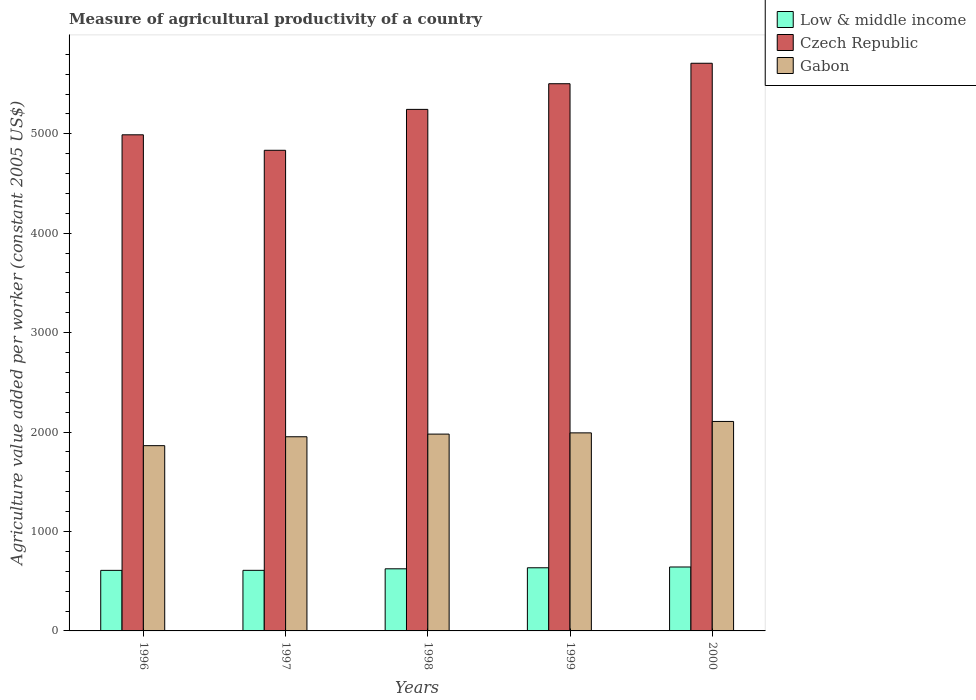How many different coloured bars are there?
Offer a terse response. 3. Are the number of bars on each tick of the X-axis equal?
Offer a terse response. Yes. How many bars are there on the 5th tick from the left?
Your response must be concise. 3. How many bars are there on the 5th tick from the right?
Provide a short and direct response. 3. What is the label of the 1st group of bars from the left?
Your response must be concise. 1996. What is the measure of agricultural productivity in Low & middle income in 1998?
Give a very brief answer. 624.77. Across all years, what is the maximum measure of agricultural productivity in Low & middle income?
Give a very brief answer. 643.04. Across all years, what is the minimum measure of agricultural productivity in Low & middle income?
Ensure brevity in your answer.  609. What is the total measure of agricultural productivity in Gabon in the graph?
Give a very brief answer. 9894.6. What is the difference between the measure of agricultural productivity in Czech Republic in 1998 and that in 1999?
Provide a short and direct response. -258.04. What is the difference between the measure of agricultural productivity in Gabon in 1999 and the measure of agricultural productivity in Low & middle income in 1996?
Provide a succinct answer. 1383. What is the average measure of agricultural productivity in Czech Republic per year?
Offer a very short reply. 5256.4. In the year 1998, what is the difference between the measure of agricultural productivity in Gabon and measure of agricultural productivity in Czech Republic?
Make the answer very short. -3265.87. What is the ratio of the measure of agricultural productivity in Low & middle income in 1996 to that in 2000?
Offer a terse response. 0.95. What is the difference between the highest and the second highest measure of agricultural productivity in Czech Republic?
Keep it short and to the point. 205.87. What is the difference between the highest and the lowest measure of agricultural productivity in Gabon?
Provide a succinct answer. 243.62. In how many years, is the measure of agricultural productivity in Czech Republic greater than the average measure of agricultural productivity in Czech Republic taken over all years?
Provide a short and direct response. 2. What does the 3rd bar from the left in 1997 represents?
Offer a terse response. Gabon. What does the 2nd bar from the right in 2000 represents?
Your answer should be very brief. Czech Republic. Are all the bars in the graph horizontal?
Offer a very short reply. No. Does the graph contain any zero values?
Offer a terse response. No. How are the legend labels stacked?
Offer a terse response. Vertical. What is the title of the graph?
Offer a terse response. Measure of agricultural productivity of a country. What is the label or title of the X-axis?
Your response must be concise. Years. What is the label or title of the Y-axis?
Make the answer very short. Agriculture value added per worker (constant 2005 US$). What is the Agriculture value added per worker (constant 2005 US$) of Low & middle income in 1996?
Keep it short and to the point. 609. What is the Agriculture value added per worker (constant 2005 US$) in Czech Republic in 1996?
Offer a very short reply. 4989.73. What is the Agriculture value added per worker (constant 2005 US$) of Gabon in 1996?
Offer a terse response. 1863.27. What is the Agriculture value added per worker (constant 2005 US$) in Low & middle income in 1997?
Your answer should be very brief. 609.28. What is the Agriculture value added per worker (constant 2005 US$) in Czech Republic in 1997?
Your answer should be very brief. 4833.99. What is the Agriculture value added per worker (constant 2005 US$) in Gabon in 1997?
Your answer should be compact. 1952.85. What is the Agriculture value added per worker (constant 2005 US$) in Low & middle income in 1998?
Provide a short and direct response. 624.77. What is the Agriculture value added per worker (constant 2005 US$) of Czech Republic in 1998?
Provide a short and direct response. 5245.45. What is the Agriculture value added per worker (constant 2005 US$) of Gabon in 1998?
Offer a terse response. 1979.57. What is the Agriculture value added per worker (constant 2005 US$) in Low & middle income in 1999?
Give a very brief answer. 635.15. What is the Agriculture value added per worker (constant 2005 US$) in Czech Republic in 1999?
Ensure brevity in your answer.  5503.49. What is the Agriculture value added per worker (constant 2005 US$) in Gabon in 1999?
Offer a terse response. 1992. What is the Agriculture value added per worker (constant 2005 US$) in Low & middle income in 2000?
Provide a succinct answer. 643.04. What is the Agriculture value added per worker (constant 2005 US$) of Czech Republic in 2000?
Offer a terse response. 5709.36. What is the Agriculture value added per worker (constant 2005 US$) of Gabon in 2000?
Provide a short and direct response. 2106.9. Across all years, what is the maximum Agriculture value added per worker (constant 2005 US$) in Low & middle income?
Give a very brief answer. 643.04. Across all years, what is the maximum Agriculture value added per worker (constant 2005 US$) of Czech Republic?
Keep it short and to the point. 5709.36. Across all years, what is the maximum Agriculture value added per worker (constant 2005 US$) of Gabon?
Provide a succinct answer. 2106.9. Across all years, what is the minimum Agriculture value added per worker (constant 2005 US$) of Low & middle income?
Your answer should be very brief. 609. Across all years, what is the minimum Agriculture value added per worker (constant 2005 US$) in Czech Republic?
Offer a terse response. 4833.99. Across all years, what is the minimum Agriculture value added per worker (constant 2005 US$) of Gabon?
Ensure brevity in your answer.  1863.27. What is the total Agriculture value added per worker (constant 2005 US$) of Low & middle income in the graph?
Keep it short and to the point. 3121.24. What is the total Agriculture value added per worker (constant 2005 US$) of Czech Republic in the graph?
Offer a terse response. 2.63e+04. What is the total Agriculture value added per worker (constant 2005 US$) in Gabon in the graph?
Offer a very short reply. 9894.6. What is the difference between the Agriculture value added per worker (constant 2005 US$) of Low & middle income in 1996 and that in 1997?
Provide a short and direct response. -0.28. What is the difference between the Agriculture value added per worker (constant 2005 US$) in Czech Republic in 1996 and that in 1997?
Provide a succinct answer. 155.74. What is the difference between the Agriculture value added per worker (constant 2005 US$) in Gabon in 1996 and that in 1997?
Ensure brevity in your answer.  -89.58. What is the difference between the Agriculture value added per worker (constant 2005 US$) in Low & middle income in 1996 and that in 1998?
Your answer should be compact. -15.77. What is the difference between the Agriculture value added per worker (constant 2005 US$) in Czech Republic in 1996 and that in 1998?
Your answer should be very brief. -255.72. What is the difference between the Agriculture value added per worker (constant 2005 US$) in Gabon in 1996 and that in 1998?
Give a very brief answer. -116.3. What is the difference between the Agriculture value added per worker (constant 2005 US$) of Low & middle income in 1996 and that in 1999?
Give a very brief answer. -26.15. What is the difference between the Agriculture value added per worker (constant 2005 US$) of Czech Republic in 1996 and that in 1999?
Your response must be concise. -513.76. What is the difference between the Agriculture value added per worker (constant 2005 US$) of Gabon in 1996 and that in 1999?
Your answer should be very brief. -128.73. What is the difference between the Agriculture value added per worker (constant 2005 US$) of Low & middle income in 1996 and that in 2000?
Provide a succinct answer. -34.04. What is the difference between the Agriculture value added per worker (constant 2005 US$) of Czech Republic in 1996 and that in 2000?
Provide a succinct answer. -719.63. What is the difference between the Agriculture value added per worker (constant 2005 US$) in Gabon in 1996 and that in 2000?
Ensure brevity in your answer.  -243.62. What is the difference between the Agriculture value added per worker (constant 2005 US$) in Low & middle income in 1997 and that in 1998?
Ensure brevity in your answer.  -15.5. What is the difference between the Agriculture value added per worker (constant 2005 US$) of Czech Republic in 1997 and that in 1998?
Make the answer very short. -411.46. What is the difference between the Agriculture value added per worker (constant 2005 US$) in Gabon in 1997 and that in 1998?
Keep it short and to the point. -26.72. What is the difference between the Agriculture value added per worker (constant 2005 US$) of Low & middle income in 1997 and that in 1999?
Your answer should be very brief. -25.87. What is the difference between the Agriculture value added per worker (constant 2005 US$) in Czech Republic in 1997 and that in 1999?
Offer a very short reply. -669.5. What is the difference between the Agriculture value added per worker (constant 2005 US$) of Gabon in 1997 and that in 1999?
Provide a succinct answer. -39.15. What is the difference between the Agriculture value added per worker (constant 2005 US$) of Low & middle income in 1997 and that in 2000?
Make the answer very short. -33.76. What is the difference between the Agriculture value added per worker (constant 2005 US$) of Czech Republic in 1997 and that in 2000?
Your response must be concise. -875.37. What is the difference between the Agriculture value added per worker (constant 2005 US$) in Gabon in 1997 and that in 2000?
Offer a terse response. -154.04. What is the difference between the Agriculture value added per worker (constant 2005 US$) of Low & middle income in 1998 and that in 1999?
Give a very brief answer. -10.38. What is the difference between the Agriculture value added per worker (constant 2005 US$) in Czech Republic in 1998 and that in 1999?
Keep it short and to the point. -258.04. What is the difference between the Agriculture value added per worker (constant 2005 US$) of Gabon in 1998 and that in 1999?
Give a very brief answer. -12.43. What is the difference between the Agriculture value added per worker (constant 2005 US$) in Low & middle income in 1998 and that in 2000?
Keep it short and to the point. -18.26. What is the difference between the Agriculture value added per worker (constant 2005 US$) in Czech Republic in 1998 and that in 2000?
Ensure brevity in your answer.  -463.91. What is the difference between the Agriculture value added per worker (constant 2005 US$) in Gabon in 1998 and that in 2000?
Make the answer very short. -127.32. What is the difference between the Agriculture value added per worker (constant 2005 US$) of Low & middle income in 1999 and that in 2000?
Provide a succinct answer. -7.89. What is the difference between the Agriculture value added per worker (constant 2005 US$) in Czech Republic in 1999 and that in 2000?
Offer a terse response. -205.87. What is the difference between the Agriculture value added per worker (constant 2005 US$) of Gabon in 1999 and that in 2000?
Your answer should be very brief. -114.89. What is the difference between the Agriculture value added per worker (constant 2005 US$) in Low & middle income in 1996 and the Agriculture value added per worker (constant 2005 US$) in Czech Republic in 1997?
Offer a terse response. -4224.99. What is the difference between the Agriculture value added per worker (constant 2005 US$) of Low & middle income in 1996 and the Agriculture value added per worker (constant 2005 US$) of Gabon in 1997?
Provide a succinct answer. -1343.85. What is the difference between the Agriculture value added per worker (constant 2005 US$) in Czech Republic in 1996 and the Agriculture value added per worker (constant 2005 US$) in Gabon in 1997?
Give a very brief answer. 3036.88. What is the difference between the Agriculture value added per worker (constant 2005 US$) in Low & middle income in 1996 and the Agriculture value added per worker (constant 2005 US$) in Czech Republic in 1998?
Keep it short and to the point. -4636.45. What is the difference between the Agriculture value added per worker (constant 2005 US$) in Low & middle income in 1996 and the Agriculture value added per worker (constant 2005 US$) in Gabon in 1998?
Give a very brief answer. -1370.57. What is the difference between the Agriculture value added per worker (constant 2005 US$) of Czech Republic in 1996 and the Agriculture value added per worker (constant 2005 US$) of Gabon in 1998?
Make the answer very short. 3010.16. What is the difference between the Agriculture value added per worker (constant 2005 US$) in Low & middle income in 1996 and the Agriculture value added per worker (constant 2005 US$) in Czech Republic in 1999?
Your response must be concise. -4894.49. What is the difference between the Agriculture value added per worker (constant 2005 US$) of Low & middle income in 1996 and the Agriculture value added per worker (constant 2005 US$) of Gabon in 1999?
Provide a succinct answer. -1383. What is the difference between the Agriculture value added per worker (constant 2005 US$) in Czech Republic in 1996 and the Agriculture value added per worker (constant 2005 US$) in Gabon in 1999?
Make the answer very short. 2997.73. What is the difference between the Agriculture value added per worker (constant 2005 US$) of Low & middle income in 1996 and the Agriculture value added per worker (constant 2005 US$) of Czech Republic in 2000?
Your answer should be very brief. -5100.36. What is the difference between the Agriculture value added per worker (constant 2005 US$) in Low & middle income in 1996 and the Agriculture value added per worker (constant 2005 US$) in Gabon in 2000?
Your answer should be very brief. -1497.9. What is the difference between the Agriculture value added per worker (constant 2005 US$) in Czech Republic in 1996 and the Agriculture value added per worker (constant 2005 US$) in Gabon in 2000?
Offer a terse response. 2882.83. What is the difference between the Agriculture value added per worker (constant 2005 US$) in Low & middle income in 1997 and the Agriculture value added per worker (constant 2005 US$) in Czech Republic in 1998?
Your response must be concise. -4636.17. What is the difference between the Agriculture value added per worker (constant 2005 US$) of Low & middle income in 1997 and the Agriculture value added per worker (constant 2005 US$) of Gabon in 1998?
Offer a very short reply. -1370.3. What is the difference between the Agriculture value added per worker (constant 2005 US$) of Czech Republic in 1997 and the Agriculture value added per worker (constant 2005 US$) of Gabon in 1998?
Give a very brief answer. 2854.42. What is the difference between the Agriculture value added per worker (constant 2005 US$) of Low & middle income in 1997 and the Agriculture value added per worker (constant 2005 US$) of Czech Republic in 1999?
Provide a short and direct response. -4894.21. What is the difference between the Agriculture value added per worker (constant 2005 US$) of Low & middle income in 1997 and the Agriculture value added per worker (constant 2005 US$) of Gabon in 1999?
Offer a very short reply. -1382.72. What is the difference between the Agriculture value added per worker (constant 2005 US$) of Czech Republic in 1997 and the Agriculture value added per worker (constant 2005 US$) of Gabon in 1999?
Keep it short and to the point. 2841.99. What is the difference between the Agriculture value added per worker (constant 2005 US$) of Low & middle income in 1997 and the Agriculture value added per worker (constant 2005 US$) of Czech Republic in 2000?
Give a very brief answer. -5100.08. What is the difference between the Agriculture value added per worker (constant 2005 US$) in Low & middle income in 1997 and the Agriculture value added per worker (constant 2005 US$) in Gabon in 2000?
Give a very brief answer. -1497.62. What is the difference between the Agriculture value added per worker (constant 2005 US$) in Czech Republic in 1997 and the Agriculture value added per worker (constant 2005 US$) in Gabon in 2000?
Your response must be concise. 2727.09. What is the difference between the Agriculture value added per worker (constant 2005 US$) in Low & middle income in 1998 and the Agriculture value added per worker (constant 2005 US$) in Czech Republic in 1999?
Provide a succinct answer. -4878.71. What is the difference between the Agriculture value added per worker (constant 2005 US$) of Low & middle income in 1998 and the Agriculture value added per worker (constant 2005 US$) of Gabon in 1999?
Make the answer very short. -1367.23. What is the difference between the Agriculture value added per worker (constant 2005 US$) of Czech Republic in 1998 and the Agriculture value added per worker (constant 2005 US$) of Gabon in 1999?
Ensure brevity in your answer.  3253.45. What is the difference between the Agriculture value added per worker (constant 2005 US$) of Low & middle income in 1998 and the Agriculture value added per worker (constant 2005 US$) of Czech Republic in 2000?
Your response must be concise. -5084.59. What is the difference between the Agriculture value added per worker (constant 2005 US$) of Low & middle income in 1998 and the Agriculture value added per worker (constant 2005 US$) of Gabon in 2000?
Ensure brevity in your answer.  -1482.12. What is the difference between the Agriculture value added per worker (constant 2005 US$) in Czech Republic in 1998 and the Agriculture value added per worker (constant 2005 US$) in Gabon in 2000?
Offer a very short reply. 3138.55. What is the difference between the Agriculture value added per worker (constant 2005 US$) in Low & middle income in 1999 and the Agriculture value added per worker (constant 2005 US$) in Czech Republic in 2000?
Provide a short and direct response. -5074.21. What is the difference between the Agriculture value added per worker (constant 2005 US$) in Low & middle income in 1999 and the Agriculture value added per worker (constant 2005 US$) in Gabon in 2000?
Make the answer very short. -1471.74. What is the difference between the Agriculture value added per worker (constant 2005 US$) in Czech Republic in 1999 and the Agriculture value added per worker (constant 2005 US$) in Gabon in 2000?
Provide a succinct answer. 3396.59. What is the average Agriculture value added per worker (constant 2005 US$) of Low & middle income per year?
Provide a short and direct response. 624.25. What is the average Agriculture value added per worker (constant 2005 US$) in Czech Republic per year?
Provide a short and direct response. 5256.4. What is the average Agriculture value added per worker (constant 2005 US$) of Gabon per year?
Make the answer very short. 1978.92. In the year 1996, what is the difference between the Agriculture value added per worker (constant 2005 US$) of Low & middle income and Agriculture value added per worker (constant 2005 US$) of Czech Republic?
Offer a terse response. -4380.73. In the year 1996, what is the difference between the Agriculture value added per worker (constant 2005 US$) of Low & middle income and Agriculture value added per worker (constant 2005 US$) of Gabon?
Your response must be concise. -1254.27. In the year 1996, what is the difference between the Agriculture value added per worker (constant 2005 US$) of Czech Republic and Agriculture value added per worker (constant 2005 US$) of Gabon?
Give a very brief answer. 3126.46. In the year 1997, what is the difference between the Agriculture value added per worker (constant 2005 US$) of Low & middle income and Agriculture value added per worker (constant 2005 US$) of Czech Republic?
Provide a succinct answer. -4224.71. In the year 1997, what is the difference between the Agriculture value added per worker (constant 2005 US$) in Low & middle income and Agriculture value added per worker (constant 2005 US$) in Gabon?
Offer a very short reply. -1343.57. In the year 1997, what is the difference between the Agriculture value added per worker (constant 2005 US$) in Czech Republic and Agriculture value added per worker (constant 2005 US$) in Gabon?
Your answer should be very brief. 2881.14. In the year 1998, what is the difference between the Agriculture value added per worker (constant 2005 US$) in Low & middle income and Agriculture value added per worker (constant 2005 US$) in Czech Republic?
Your answer should be compact. -4620.67. In the year 1998, what is the difference between the Agriculture value added per worker (constant 2005 US$) of Low & middle income and Agriculture value added per worker (constant 2005 US$) of Gabon?
Ensure brevity in your answer.  -1354.8. In the year 1998, what is the difference between the Agriculture value added per worker (constant 2005 US$) in Czech Republic and Agriculture value added per worker (constant 2005 US$) in Gabon?
Provide a succinct answer. 3265.87. In the year 1999, what is the difference between the Agriculture value added per worker (constant 2005 US$) in Low & middle income and Agriculture value added per worker (constant 2005 US$) in Czech Republic?
Keep it short and to the point. -4868.34. In the year 1999, what is the difference between the Agriculture value added per worker (constant 2005 US$) of Low & middle income and Agriculture value added per worker (constant 2005 US$) of Gabon?
Provide a succinct answer. -1356.85. In the year 1999, what is the difference between the Agriculture value added per worker (constant 2005 US$) in Czech Republic and Agriculture value added per worker (constant 2005 US$) in Gabon?
Make the answer very short. 3511.49. In the year 2000, what is the difference between the Agriculture value added per worker (constant 2005 US$) of Low & middle income and Agriculture value added per worker (constant 2005 US$) of Czech Republic?
Your answer should be very brief. -5066.32. In the year 2000, what is the difference between the Agriculture value added per worker (constant 2005 US$) of Low & middle income and Agriculture value added per worker (constant 2005 US$) of Gabon?
Give a very brief answer. -1463.86. In the year 2000, what is the difference between the Agriculture value added per worker (constant 2005 US$) in Czech Republic and Agriculture value added per worker (constant 2005 US$) in Gabon?
Make the answer very short. 3602.46. What is the ratio of the Agriculture value added per worker (constant 2005 US$) in Low & middle income in 1996 to that in 1997?
Provide a succinct answer. 1. What is the ratio of the Agriculture value added per worker (constant 2005 US$) of Czech Republic in 1996 to that in 1997?
Your response must be concise. 1.03. What is the ratio of the Agriculture value added per worker (constant 2005 US$) in Gabon in 1996 to that in 1997?
Provide a short and direct response. 0.95. What is the ratio of the Agriculture value added per worker (constant 2005 US$) in Low & middle income in 1996 to that in 1998?
Your response must be concise. 0.97. What is the ratio of the Agriculture value added per worker (constant 2005 US$) in Czech Republic in 1996 to that in 1998?
Your answer should be compact. 0.95. What is the ratio of the Agriculture value added per worker (constant 2005 US$) in Low & middle income in 1996 to that in 1999?
Provide a succinct answer. 0.96. What is the ratio of the Agriculture value added per worker (constant 2005 US$) in Czech Republic in 1996 to that in 1999?
Give a very brief answer. 0.91. What is the ratio of the Agriculture value added per worker (constant 2005 US$) of Gabon in 1996 to that in 1999?
Offer a terse response. 0.94. What is the ratio of the Agriculture value added per worker (constant 2005 US$) of Low & middle income in 1996 to that in 2000?
Offer a terse response. 0.95. What is the ratio of the Agriculture value added per worker (constant 2005 US$) in Czech Republic in 1996 to that in 2000?
Make the answer very short. 0.87. What is the ratio of the Agriculture value added per worker (constant 2005 US$) of Gabon in 1996 to that in 2000?
Your answer should be compact. 0.88. What is the ratio of the Agriculture value added per worker (constant 2005 US$) of Low & middle income in 1997 to that in 1998?
Your response must be concise. 0.98. What is the ratio of the Agriculture value added per worker (constant 2005 US$) in Czech Republic in 1997 to that in 1998?
Offer a terse response. 0.92. What is the ratio of the Agriculture value added per worker (constant 2005 US$) of Gabon in 1997 to that in 1998?
Ensure brevity in your answer.  0.99. What is the ratio of the Agriculture value added per worker (constant 2005 US$) in Low & middle income in 1997 to that in 1999?
Offer a terse response. 0.96. What is the ratio of the Agriculture value added per worker (constant 2005 US$) of Czech Republic in 1997 to that in 1999?
Your answer should be compact. 0.88. What is the ratio of the Agriculture value added per worker (constant 2005 US$) in Gabon in 1997 to that in 1999?
Your answer should be very brief. 0.98. What is the ratio of the Agriculture value added per worker (constant 2005 US$) of Low & middle income in 1997 to that in 2000?
Ensure brevity in your answer.  0.95. What is the ratio of the Agriculture value added per worker (constant 2005 US$) of Czech Republic in 1997 to that in 2000?
Offer a terse response. 0.85. What is the ratio of the Agriculture value added per worker (constant 2005 US$) of Gabon in 1997 to that in 2000?
Ensure brevity in your answer.  0.93. What is the ratio of the Agriculture value added per worker (constant 2005 US$) of Low & middle income in 1998 to that in 1999?
Your answer should be compact. 0.98. What is the ratio of the Agriculture value added per worker (constant 2005 US$) in Czech Republic in 1998 to that in 1999?
Ensure brevity in your answer.  0.95. What is the ratio of the Agriculture value added per worker (constant 2005 US$) of Gabon in 1998 to that in 1999?
Give a very brief answer. 0.99. What is the ratio of the Agriculture value added per worker (constant 2005 US$) of Low & middle income in 1998 to that in 2000?
Ensure brevity in your answer.  0.97. What is the ratio of the Agriculture value added per worker (constant 2005 US$) in Czech Republic in 1998 to that in 2000?
Give a very brief answer. 0.92. What is the ratio of the Agriculture value added per worker (constant 2005 US$) of Gabon in 1998 to that in 2000?
Make the answer very short. 0.94. What is the ratio of the Agriculture value added per worker (constant 2005 US$) of Czech Republic in 1999 to that in 2000?
Keep it short and to the point. 0.96. What is the ratio of the Agriculture value added per worker (constant 2005 US$) in Gabon in 1999 to that in 2000?
Offer a terse response. 0.95. What is the difference between the highest and the second highest Agriculture value added per worker (constant 2005 US$) in Low & middle income?
Your answer should be compact. 7.89. What is the difference between the highest and the second highest Agriculture value added per worker (constant 2005 US$) of Czech Republic?
Provide a succinct answer. 205.87. What is the difference between the highest and the second highest Agriculture value added per worker (constant 2005 US$) of Gabon?
Provide a short and direct response. 114.89. What is the difference between the highest and the lowest Agriculture value added per worker (constant 2005 US$) of Low & middle income?
Provide a succinct answer. 34.04. What is the difference between the highest and the lowest Agriculture value added per worker (constant 2005 US$) in Czech Republic?
Keep it short and to the point. 875.37. What is the difference between the highest and the lowest Agriculture value added per worker (constant 2005 US$) in Gabon?
Provide a short and direct response. 243.62. 